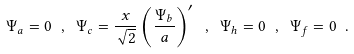<formula> <loc_0><loc_0><loc_500><loc_500>\Psi _ { a } = 0 \ , \ \Psi _ { c } = \frac { x } { \sqrt { 2 } } \left ( \frac { \Psi _ { b } } { a } \right ) ^ { \prime } \ , \ \Psi _ { h } = 0 \ , \ \Psi _ { f } = 0 \ .</formula> 